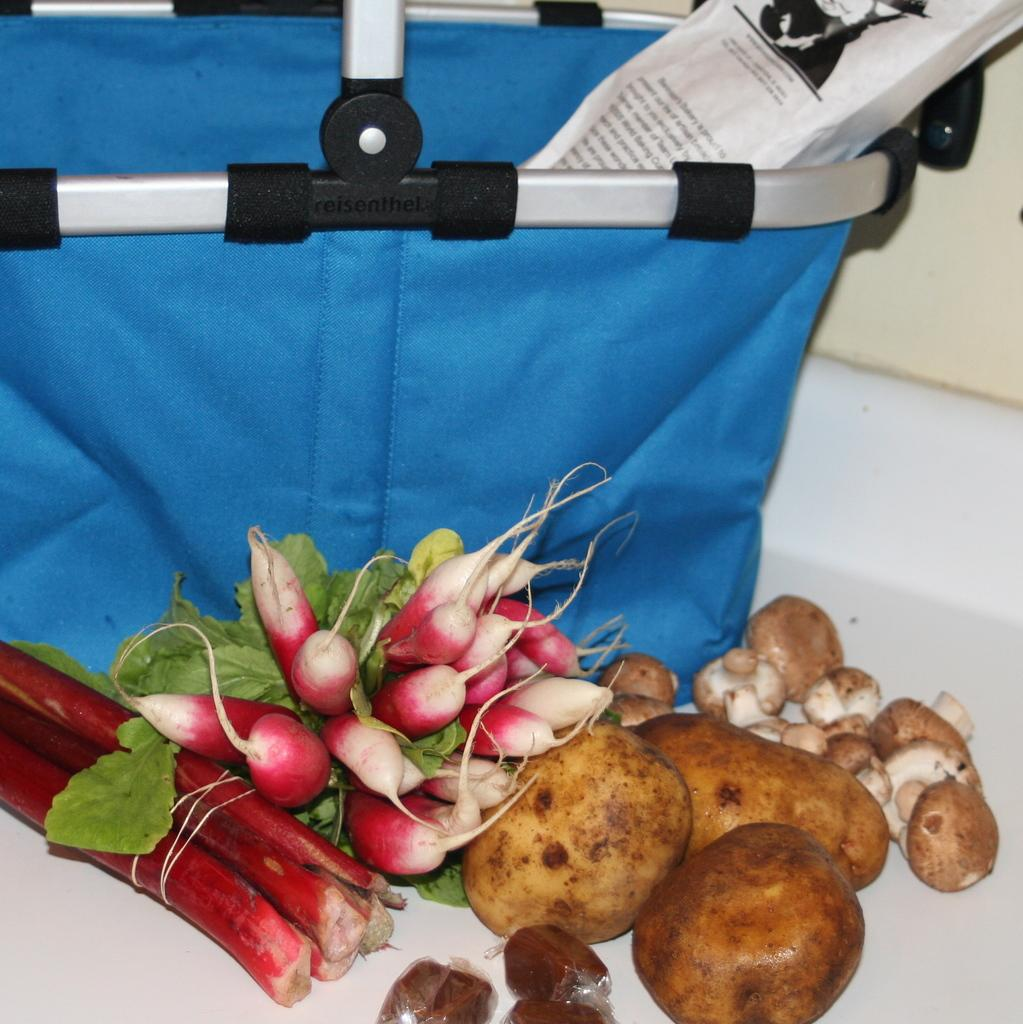What types of vegetables can be seen in the image? There are potatoes, radishes, and mushrooms in the image. How are the vegetables arranged in the image? The vegetables are placed on the ground. Is there any container or bag visible in the image? Yes, there is a blue bag in the image. What type of government is depicted in the image? There is no depiction of a government in the image; it features vegetables and a blue bag. Can you tell me how many kites are visible in the image? There are no kites present in the image. 